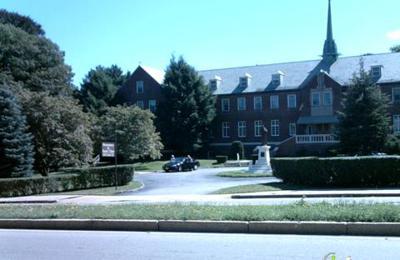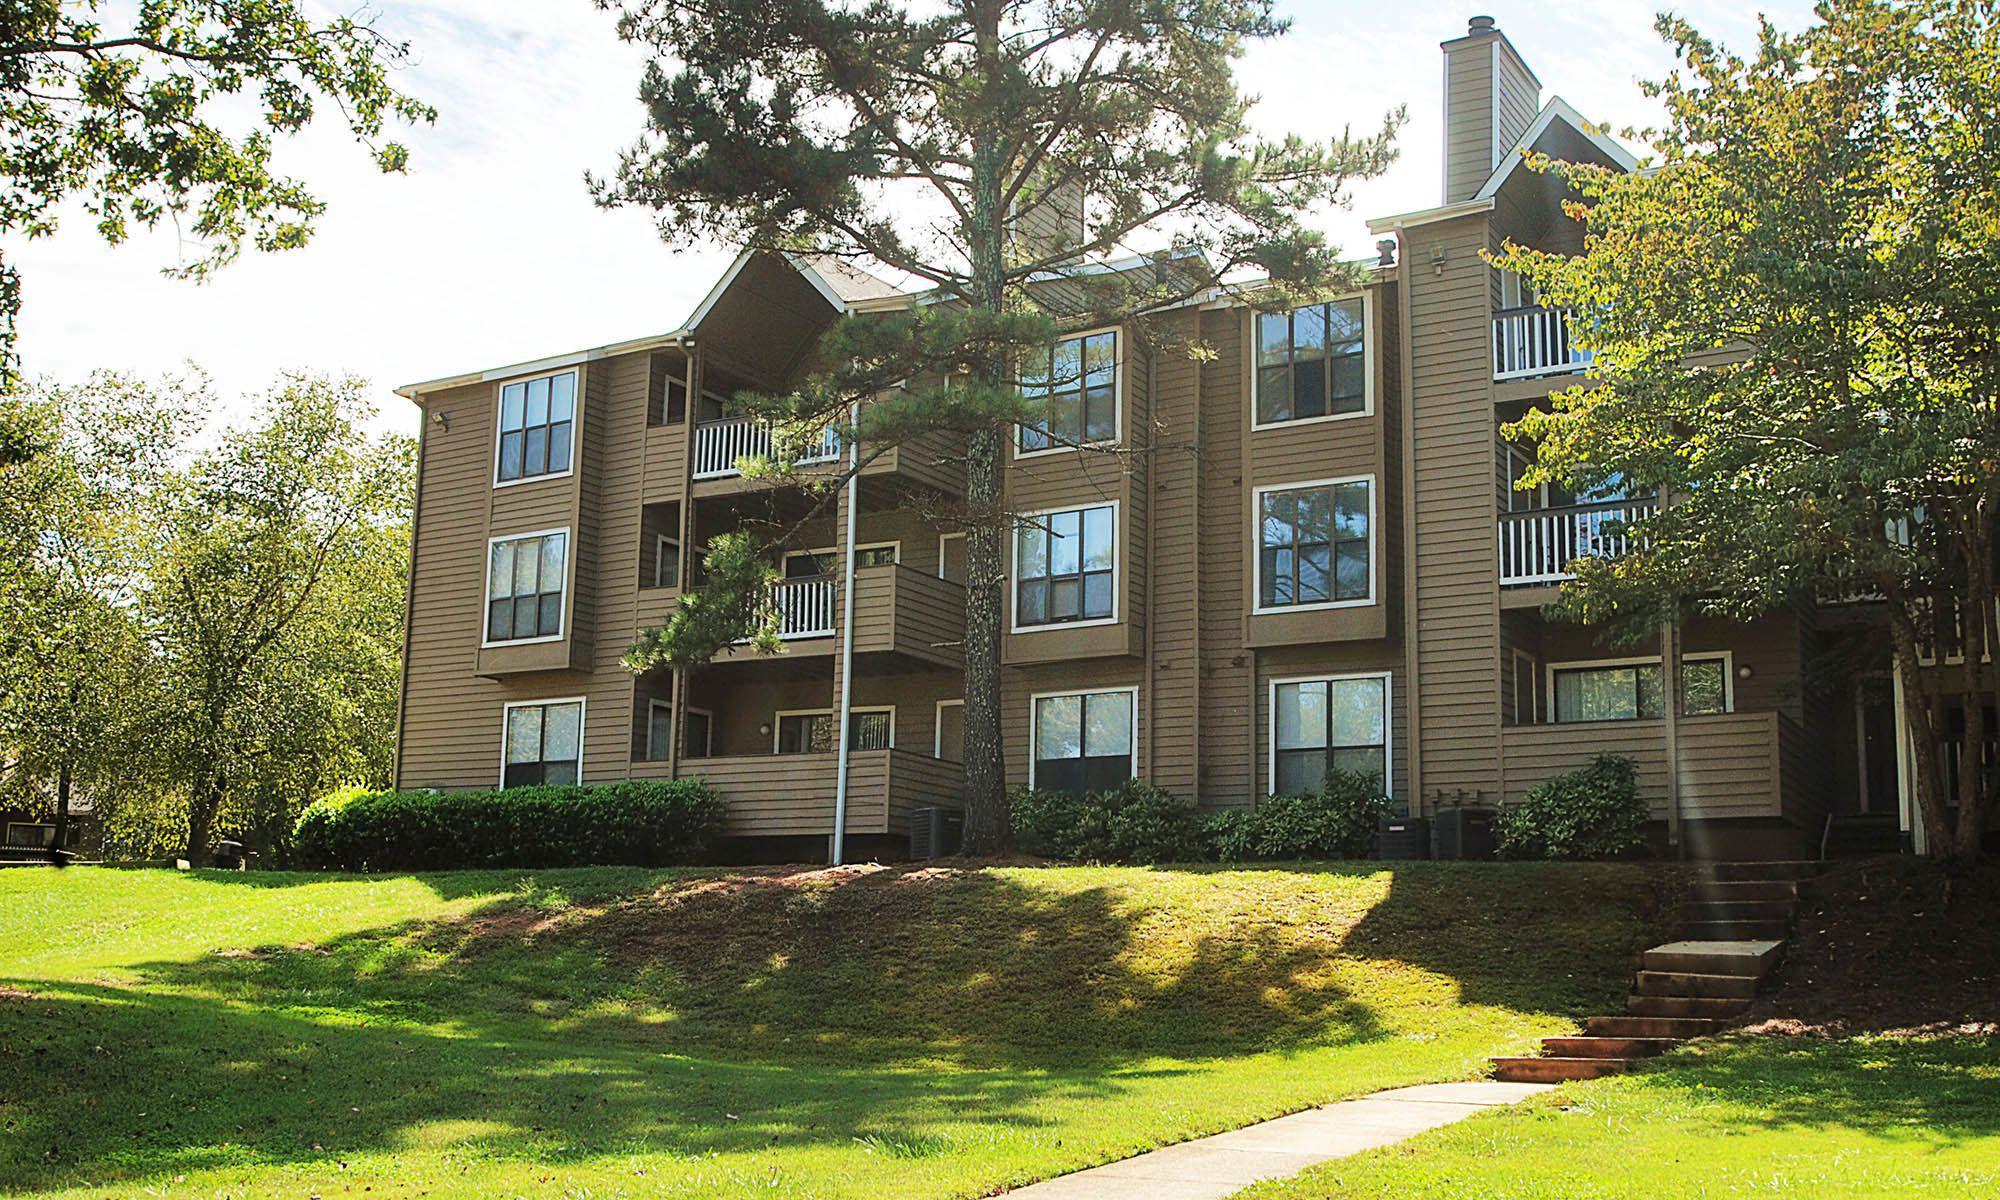The first image is the image on the left, the second image is the image on the right. Assess this claim about the two images: "There is at least one visible cross atop the building in one of the images.". Correct or not? Answer yes or no. No. The first image is the image on the left, the second image is the image on the right. Given the left and right images, does the statement "There is at least one cross atop the building in one of the images." hold true? Answer yes or no. No. 